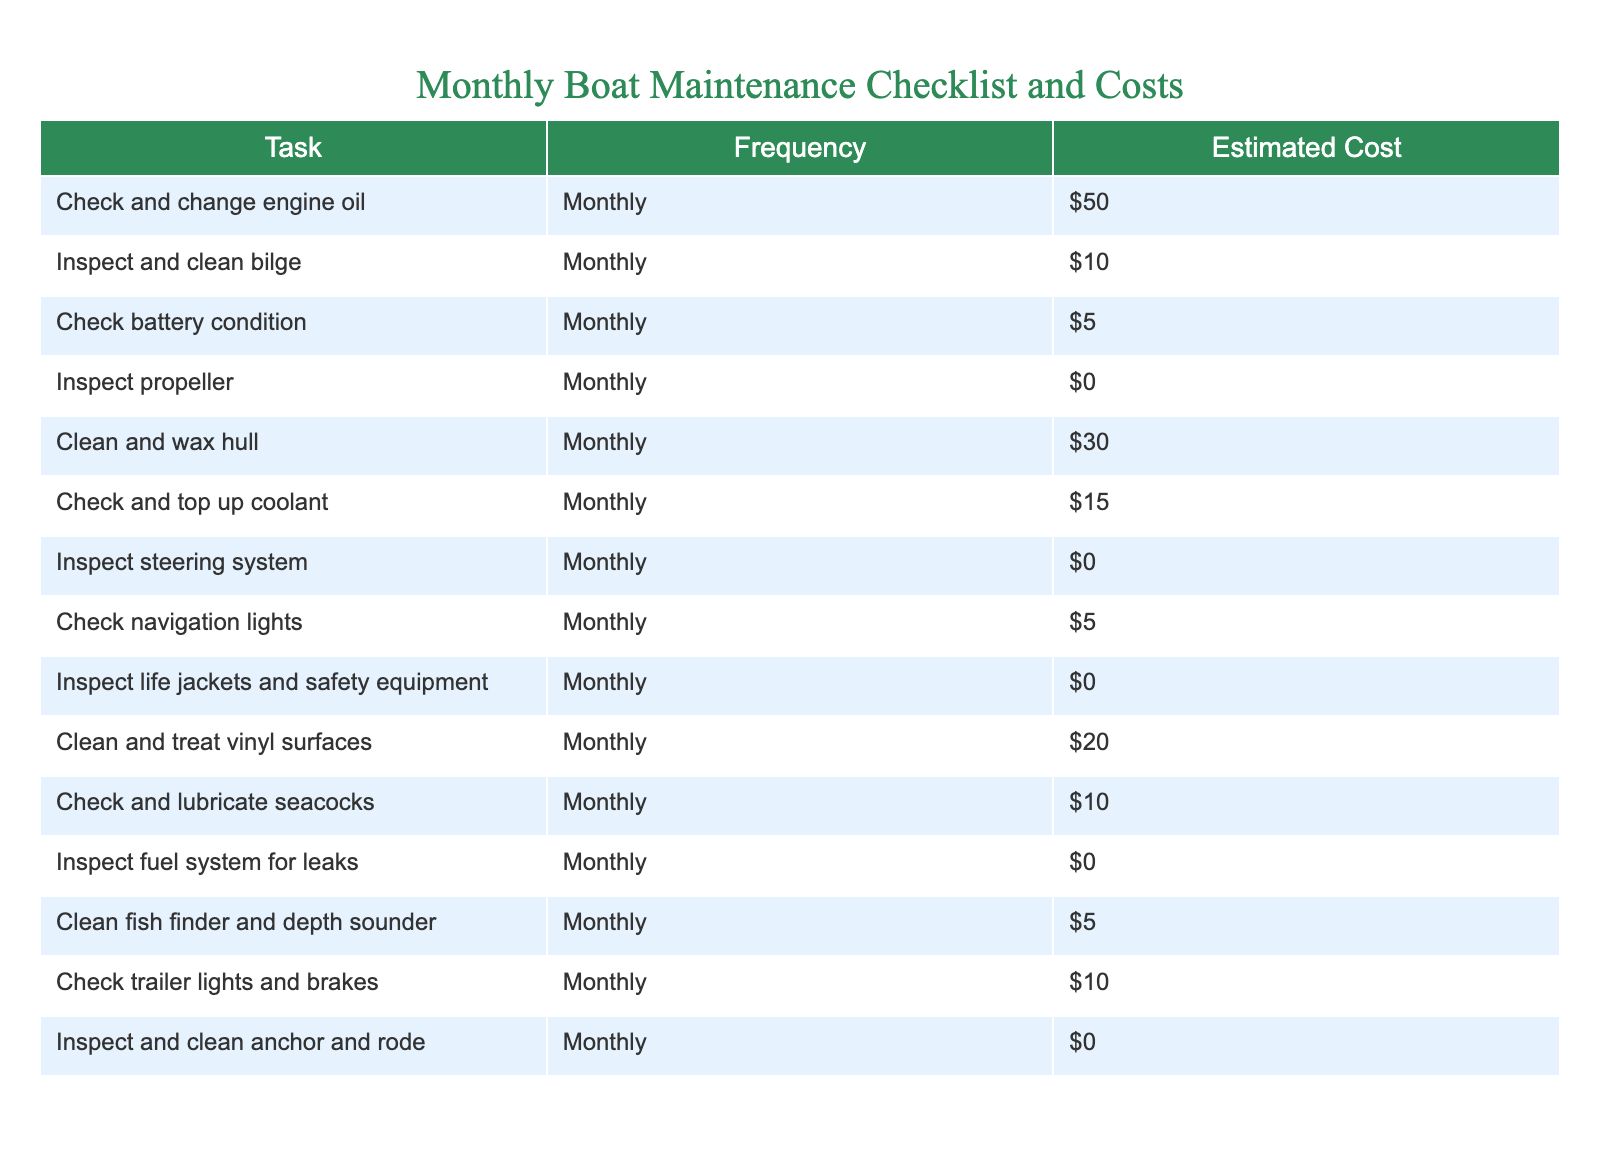What are the total estimated costs for all maintenance tasks? To find the total estimated costs, I will add up the costs from all the tasks listed in the table. The costs are: $50, $10, $5, $0, $30, $15, $0, $5, $0, $20, $10, $0, $5, $10, and $0, which totals to $50 + $10 + $5 + $0 + $30 + $15 + $0 + $5 + $0 + $20 + $10 + $0 + $5 + $10 + $0 = $265
Answer: $265 How many tasks have no associated costs? I will count the tasks that have a cost of $0 in the table. The tasks are: Inspect propeller, Inspect steering system, Inspect fuel system for leaks, Inspect and clean anchor and rode. There are 4 tasks with no costs.
Answer: 4 What is the most expensive maintenance task? To identify the most expensive maintenance task, I will look for the highest cost in the table. The highest cost is $50 for "Check and change engine oil." Therefore, this is the most expensive task.
Answer: Check and change engine oil What is the average estimated cost of all maintenance tasks? To calculate the average, I will first sum the costs ($265 as found previously) and then divide by the number of tasks, which is 15. Therefore, it's $265 / 15 = $17.67.
Answer: $17.67 Is the cost of cleaning and treating vinyl surfaces more than the average cost of maintenance tasks? I first found the average cost to be $17.67. The cost for cleaning and treating vinyl surfaces is $20. Since $20 is greater than $17.67, the answer is yes.
Answer: Yes How much more does it cost to clean and wax the hull than to check the battery condition? I will find the costs for both tasks: cleaning and waxing the hull costs $30 and checking the battery condition costs $5. The difference is $30 - $5 = $25.
Answer: $25 Are there any tasks that cost more than $15? I will check each task's cost against $15. The tasks that cost more than $15 are: "Check and change engine oil" ($50), "Clean and wax hull" ($30), and "Check and top up coolant" ($15). Thus, there are tasks that cost more than $15.
Answer: Yes What is the total cost of the tasks that involve checking something? I will isolate the tasks that include the word "check" and find their costs: "Check and change engine oil" ($50), "Check battery condition" ($5), "Check and top up coolant" ($15), "Check navigation lights" ($5), "Check trailer lights and brakes" ($10). The total is $50 + $5 + $15 + $5 + $10 = $85.
Answer: $85 